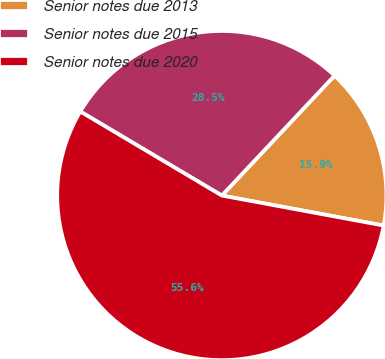<chart> <loc_0><loc_0><loc_500><loc_500><pie_chart><fcel>Senior notes due 2013<fcel>Senior notes due 2015<fcel>Senior notes due 2020<nl><fcel>15.91%<fcel>28.48%<fcel>55.61%<nl></chart> 